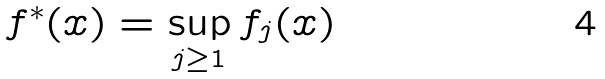<formula> <loc_0><loc_0><loc_500><loc_500>f ^ { * } ( x ) = \sup _ { j \geq 1 } f _ { j } ( x )</formula> 